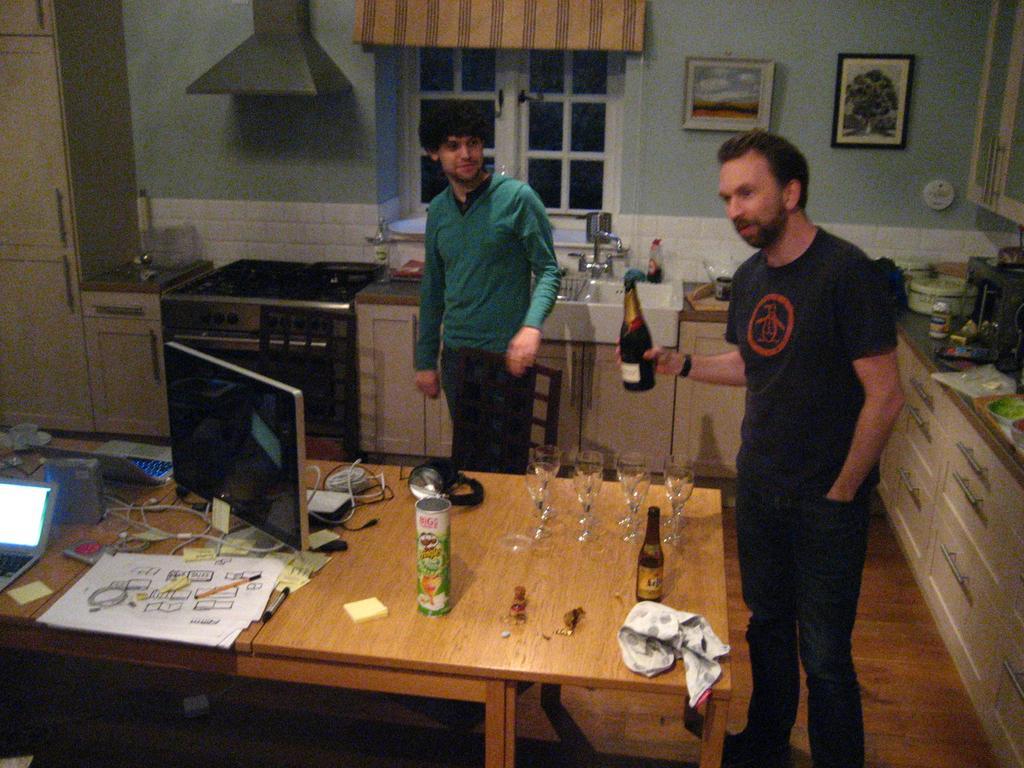How would you summarize this image in a sentence or two? In this picture there are two boys one is right side and another one is in the middle of the image, the boy who us right side of the image is holding a cool drink bottle in his hand, there are some glasses and bottles on the table with a laptop, there are desks around the area of the image, there is a window behind the front person and there are two portraits which are hanged on the wall, there are some kitchenware at the right side of the image. 